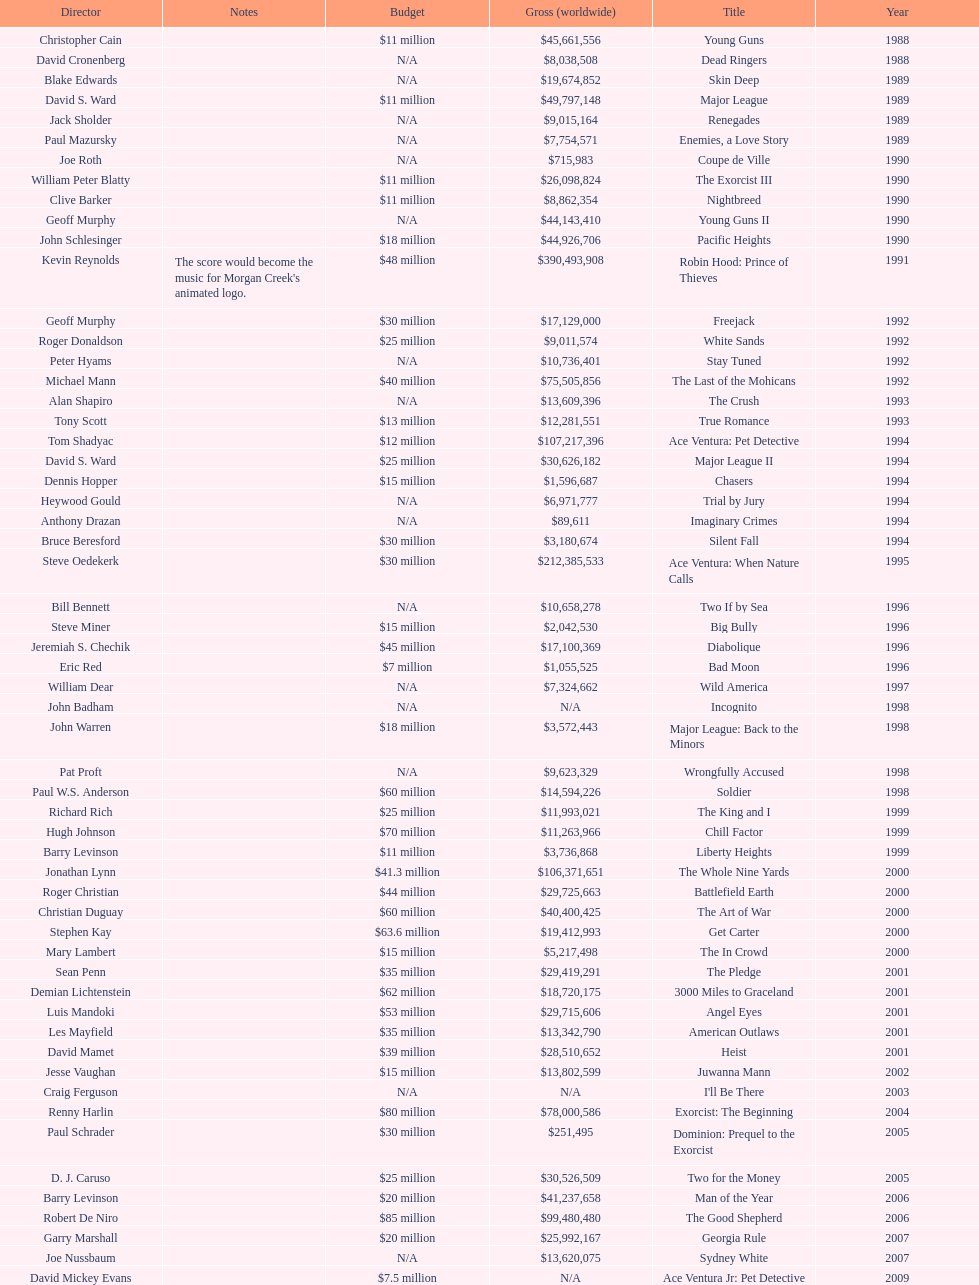What movie came out after bad moon? Wild America. Give me the full table as a dictionary. {'header': ['Director', 'Notes', 'Budget', 'Gross (worldwide)', 'Title', 'Year'], 'rows': [['Christopher Cain', '', '$11 million', '$45,661,556', 'Young Guns', '1988'], ['David Cronenberg', '', 'N/A', '$8,038,508', 'Dead Ringers', '1988'], ['Blake Edwards', '', 'N/A', '$19,674,852', 'Skin Deep', '1989'], ['David S. Ward', '', '$11 million', '$49,797,148', 'Major League', '1989'], ['Jack Sholder', '', 'N/A', '$9,015,164', 'Renegades', '1989'], ['Paul Mazursky', '', 'N/A', '$7,754,571', 'Enemies, a Love Story', '1989'], ['Joe Roth', '', 'N/A', '$715,983', 'Coupe de Ville', '1990'], ['William Peter Blatty', '', '$11 million', '$26,098,824', 'The Exorcist III', '1990'], ['Clive Barker', '', '$11 million', '$8,862,354', 'Nightbreed', '1990'], ['Geoff Murphy', '', 'N/A', '$44,143,410', 'Young Guns II', '1990'], ['John Schlesinger', '', '$18 million', '$44,926,706', 'Pacific Heights', '1990'], ['Kevin Reynolds', "The score would become the music for Morgan Creek's animated logo.", '$48 million', '$390,493,908', 'Robin Hood: Prince of Thieves', '1991'], ['Geoff Murphy', '', '$30 million', '$17,129,000', 'Freejack', '1992'], ['Roger Donaldson', '', '$25 million', '$9,011,574', 'White Sands', '1992'], ['Peter Hyams', '', 'N/A', '$10,736,401', 'Stay Tuned', '1992'], ['Michael Mann', '', '$40 million', '$75,505,856', 'The Last of the Mohicans', '1992'], ['Alan Shapiro', '', 'N/A', '$13,609,396', 'The Crush', '1993'], ['Tony Scott', '', '$13 million', '$12,281,551', 'True Romance', '1993'], ['Tom Shadyac', '', '$12 million', '$107,217,396', 'Ace Ventura: Pet Detective', '1994'], ['David S. Ward', '', '$25 million', '$30,626,182', 'Major League II', '1994'], ['Dennis Hopper', '', '$15 million', '$1,596,687', 'Chasers', '1994'], ['Heywood Gould', '', 'N/A', '$6,971,777', 'Trial by Jury', '1994'], ['Anthony Drazan', '', 'N/A', '$89,611', 'Imaginary Crimes', '1994'], ['Bruce Beresford', '', '$30 million', '$3,180,674', 'Silent Fall', '1994'], ['Steve Oedekerk', '', '$30 million', '$212,385,533', 'Ace Ventura: When Nature Calls', '1995'], ['Bill Bennett', '', 'N/A', '$10,658,278', 'Two If by Sea', '1996'], ['Steve Miner', '', '$15 million', '$2,042,530', 'Big Bully', '1996'], ['Jeremiah S. Chechik', '', '$45 million', '$17,100,369', 'Diabolique', '1996'], ['Eric Red', '', '$7 million', '$1,055,525', 'Bad Moon', '1996'], ['William Dear', '', 'N/A', '$7,324,662', 'Wild America', '1997'], ['John Badham', '', 'N/A', 'N/A', 'Incognito', '1998'], ['John Warren', '', '$18 million', '$3,572,443', 'Major League: Back to the Minors', '1998'], ['Pat Proft', '', 'N/A', '$9,623,329', 'Wrongfully Accused', '1998'], ['Paul W.S. Anderson', '', '$60 million', '$14,594,226', 'Soldier', '1998'], ['Richard Rich', '', '$25 million', '$11,993,021', 'The King and I', '1999'], ['Hugh Johnson', '', '$70 million', '$11,263,966', 'Chill Factor', '1999'], ['Barry Levinson', '', '$11 million', '$3,736,868', 'Liberty Heights', '1999'], ['Jonathan Lynn', '', '$41.3 million', '$106,371,651', 'The Whole Nine Yards', '2000'], ['Roger Christian', '', '$44 million', '$29,725,663', 'Battlefield Earth', '2000'], ['Christian Duguay', '', '$60 million', '$40,400,425', 'The Art of War', '2000'], ['Stephen Kay', '', '$63.6 million', '$19,412,993', 'Get Carter', '2000'], ['Mary Lambert', '', '$15 million', '$5,217,498', 'The In Crowd', '2000'], ['Sean Penn', '', '$35 million', '$29,419,291', 'The Pledge', '2001'], ['Demian Lichtenstein', '', '$62 million', '$18,720,175', '3000 Miles to Graceland', '2001'], ['Luis Mandoki', '', '$53 million', '$29,715,606', 'Angel Eyes', '2001'], ['Les Mayfield', '', '$35 million', '$13,342,790', 'American Outlaws', '2001'], ['David Mamet', '', '$39 million', '$28,510,652', 'Heist', '2001'], ['Jesse Vaughan', '', '$15 million', '$13,802,599', 'Juwanna Mann', '2002'], ['Craig Ferguson', '', 'N/A', 'N/A', "I'll Be There", '2003'], ['Renny Harlin', '', '$80 million', '$78,000,586', 'Exorcist: The Beginning', '2004'], ['Paul Schrader', '', '$30 million', '$251,495', 'Dominion: Prequel to the Exorcist', '2005'], ['D. J. Caruso', '', '$25 million', '$30,526,509', 'Two for the Money', '2005'], ['Barry Levinson', '', '$20 million', '$41,237,658', 'Man of the Year', '2006'], ['Robert De Niro', '', '$85 million', '$99,480,480', 'The Good Shepherd', '2006'], ['Garry Marshall', '', '$20 million', '$25,992,167', 'Georgia Rule', '2007'], ['Joe Nussbaum', '', 'N/A', '$13,620,075', 'Sydney White', '2007'], ['David Mickey Evans', '', '$7.5 million', 'N/A', 'Ace Ventura Jr: Pet Detective', '2009'], ['Jim Sheridan', '', '$50 million', '$38,502,340', 'Dream House', '2011'], ['Matthijs van Heijningen Jr.', '', '$38 million', '$27,428,670', 'The Thing', '2011'], ['Antoine Fuqua', '', '$45 million', '', 'Tupac', '2014']]} 